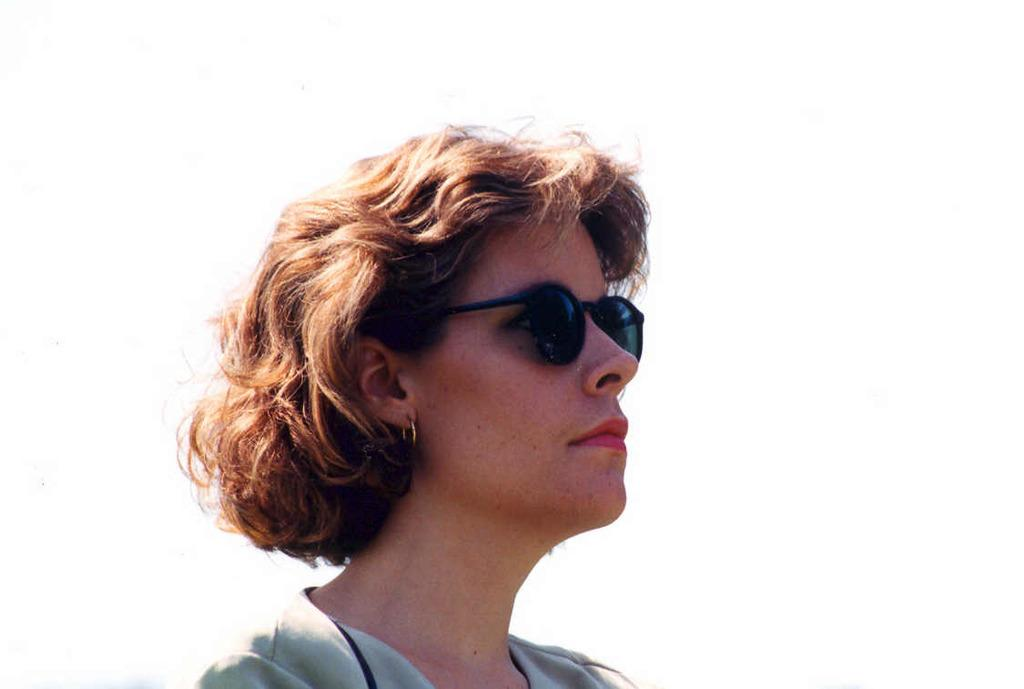Who is present in the image? There is a woman in the image. What is the woman wearing on her face? The woman is wearing a goggle. What color is the background of the image? The background of the image is white. What type of meat is being cooked in the background of the image? There is no meat or cooking activity present in the image; the background is white. 